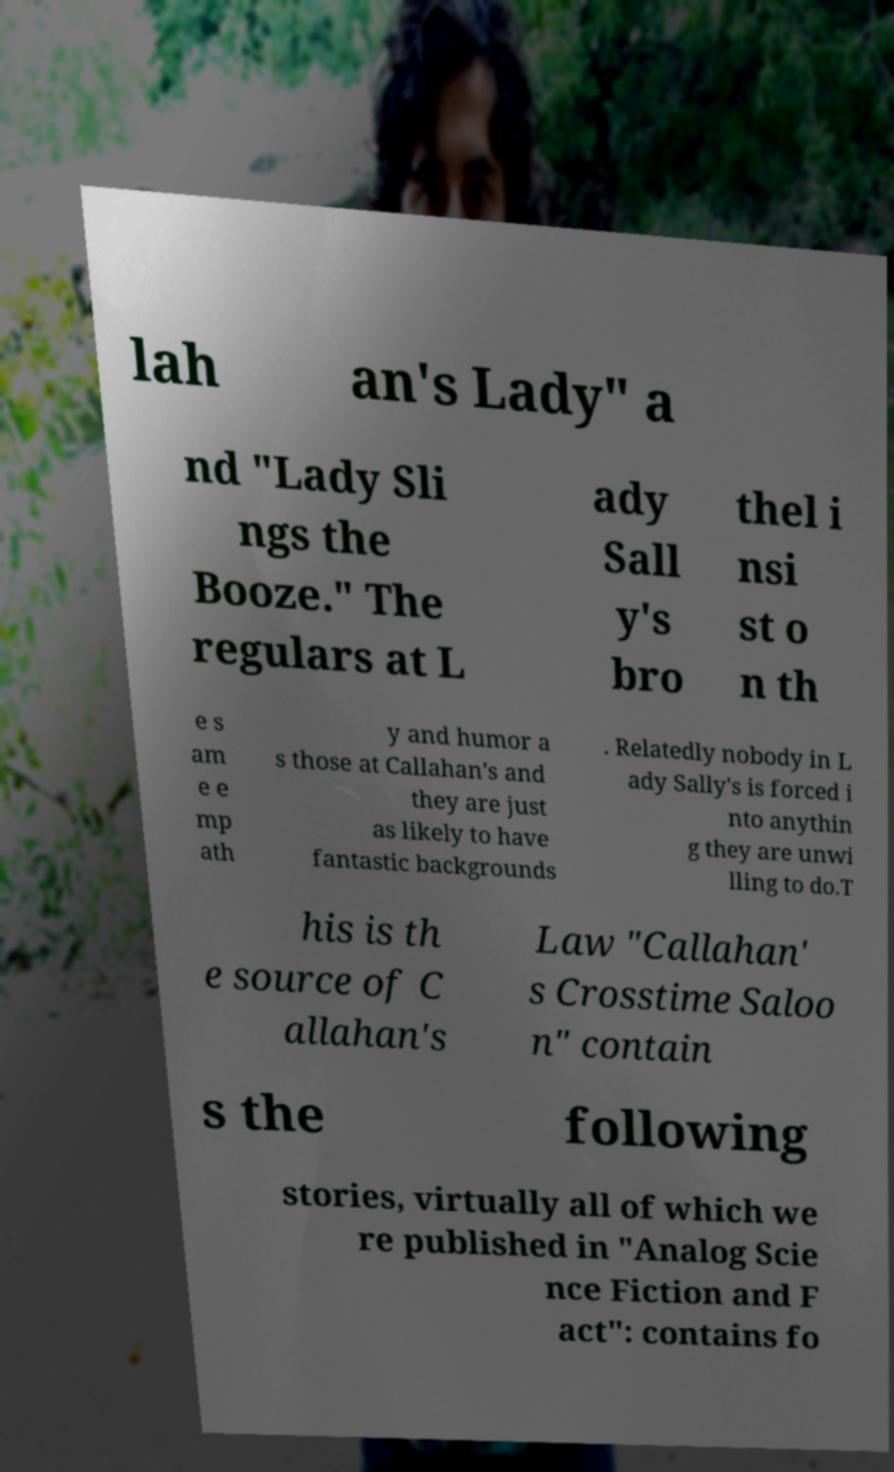Could you extract and type out the text from this image? lah an's Lady" a nd "Lady Sli ngs the Booze." The regulars at L ady Sall y's bro thel i nsi st o n th e s am e e mp ath y and humor a s those at Callahan's and they are just as likely to have fantastic backgrounds . Relatedly nobody in L ady Sally's is forced i nto anythin g they are unwi lling to do.T his is th e source of C allahan's Law "Callahan' s Crosstime Saloo n" contain s the following stories, virtually all of which we re published in "Analog Scie nce Fiction and F act": contains fo 